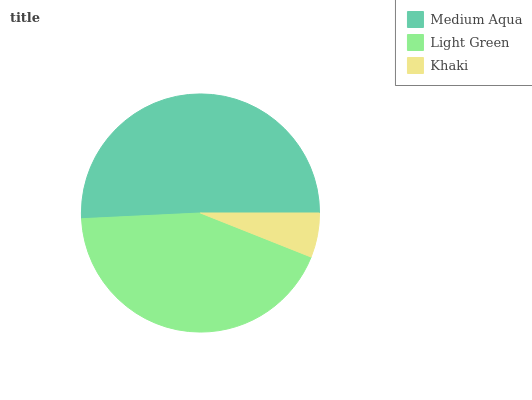Is Khaki the minimum?
Answer yes or no. Yes. Is Medium Aqua the maximum?
Answer yes or no. Yes. Is Light Green the minimum?
Answer yes or no. No. Is Light Green the maximum?
Answer yes or no. No. Is Medium Aqua greater than Light Green?
Answer yes or no. Yes. Is Light Green less than Medium Aqua?
Answer yes or no. Yes. Is Light Green greater than Medium Aqua?
Answer yes or no. No. Is Medium Aqua less than Light Green?
Answer yes or no. No. Is Light Green the high median?
Answer yes or no. Yes. Is Light Green the low median?
Answer yes or no. Yes. Is Khaki the high median?
Answer yes or no. No. Is Medium Aqua the low median?
Answer yes or no. No. 